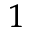Convert formula to latex. <formula><loc_0><loc_0><loc_500><loc_500>^ { 1 }</formula> 